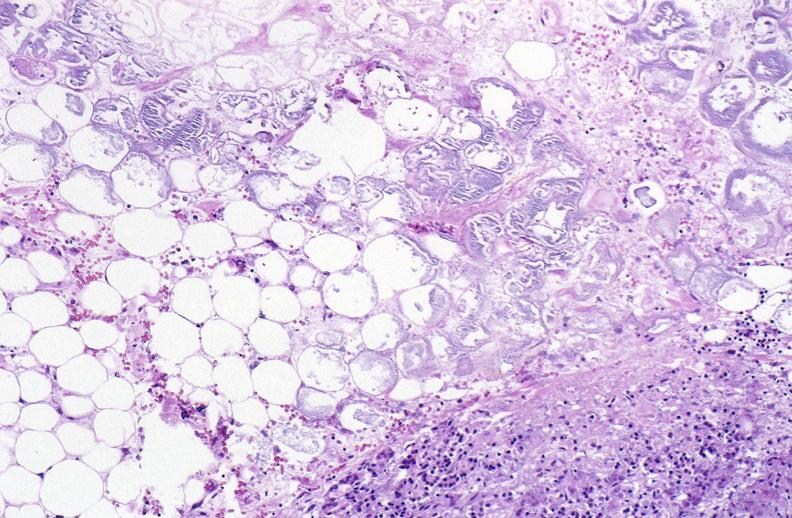does this image show pancreatic fat necrosis?
Answer the question using a single word or phrase. Yes 